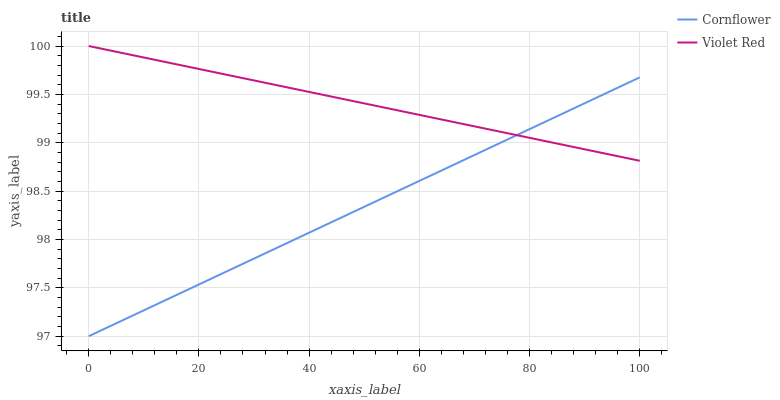Does Cornflower have the minimum area under the curve?
Answer yes or no. Yes. Does Violet Red have the maximum area under the curve?
Answer yes or no. Yes. Does Violet Red have the minimum area under the curve?
Answer yes or no. No. Is Violet Red the smoothest?
Answer yes or no. Yes. Is Cornflower the roughest?
Answer yes or no. Yes. Is Violet Red the roughest?
Answer yes or no. No. Does Cornflower have the lowest value?
Answer yes or no. Yes. Does Violet Red have the lowest value?
Answer yes or no. No. Does Violet Red have the highest value?
Answer yes or no. Yes. Does Cornflower intersect Violet Red?
Answer yes or no. Yes. Is Cornflower less than Violet Red?
Answer yes or no. No. Is Cornflower greater than Violet Red?
Answer yes or no. No. 